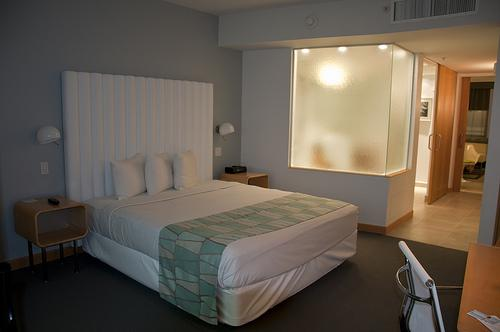Question: where is this scene?
Choices:
A. A living room.
B. A bathroom.
C. A bedroom.
D. A garage.
Answer with the letter. Answer: C Question: how many pillows are on the bed?
Choices:
A. 4.
B. 5.
C. 3.
D. 6.
Answer with the letter. Answer: C Question: where is the chair?
Choices:
A. Next to the table.
B. Next to the bed.
C. Next to the desk.
D. Next to the couch.
Answer with the letter. Answer: C Question: how is the bed?
Choices:
A. The bed is messy.
B. The bed is dirty.
C. The bed is made.
D. The bed is unmade.
Answer with the letter. Answer: C Question: where is the bathroom?
Choices:
A. Across from the kitchen.
B. To the left of the living room.
C. Next to the dining room.
D. To the right of the bed.
Answer with the letter. Answer: D 